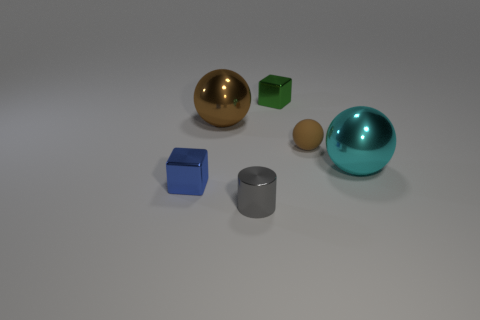Subtract all shiny balls. How many balls are left? 1 Add 2 small metallic blocks. How many objects exist? 8 Subtract all cyan blocks. How many brown spheres are left? 2 Subtract all cyan spheres. How many spheres are left? 2 Subtract all cubes. How many objects are left? 4 Subtract 2 blocks. How many blocks are left? 0 Add 1 small gray shiny cylinders. How many small gray shiny cylinders are left? 2 Add 1 large cyan metal objects. How many large cyan metal objects exist? 2 Subtract 1 blue blocks. How many objects are left? 5 Subtract all brown balls. Subtract all purple cylinders. How many balls are left? 1 